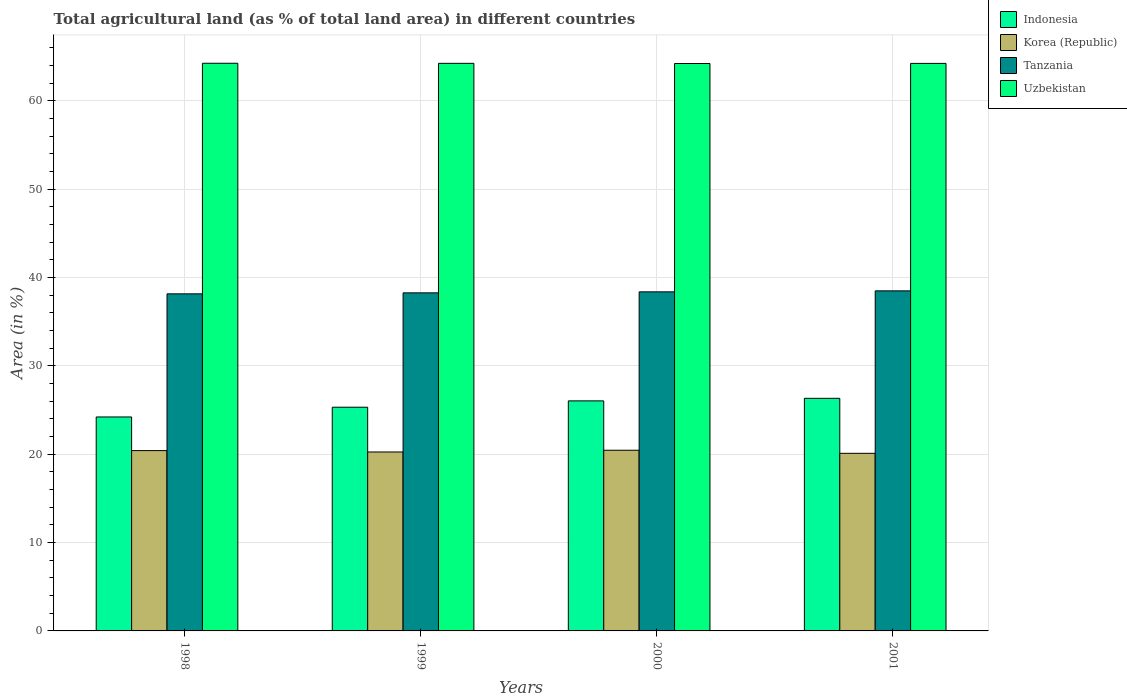Are the number of bars per tick equal to the number of legend labels?
Your answer should be compact. Yes. Are the number of bars on each tick of the X-axis equal?
Give a very brief answer. Yes. What is the percentage of agricultural land in Indonesia in 1998?
Provide a succinct answer. 24.22. Across all years, what is the maximum percentage of agricultural land in Tanzania?
Your answer should be compact. 38.5. Across all years, what is the minimum percentage of agricultural land in Korea (Republic)?
Give a very brief answer. 20.11. In which year was the percentage of agricultural land in Indonesia minimum?
Your answer should be compact. 1998. What is the total percentage of agricultural land in Tanzania in the graph?
Offer a very short reply. 153.31. What is the difference between the percentage of agricultural land in Korea (Republic) in 1998 and that in 1999?
Your answer should be compact. 0.16. What is the difference between the percentage of agricultural land in Indonesia in 2000 and the percentage of agricultural land in Korea (Republic) in 2001?
Offer a very short reply. 5.94. What is the average percentage of agricultural land in Uzbekistan per year?
Provide a succinct answer. 64.25. In the year 2001, what is the difference between the percentage of agricultural land in Korea (Republic) and percentage of agricultural land in Indonesia?
Your answer should be compact. -6.23. In how many years, is the percentage of agricultural land in Tanzania greater than 60 %?
Provide a succinct answer. 0. What is the ratio of the percentage of agricultural land in Uzbekistan in 1999 to that in 2001?
Offer a very short reply. 1. Is the percentage of agricultural land in Uzbekistan in 1999 less than that in 2000?
Ensure brevity in your answer.  No. What is the difference between the highest and the second highest percentage of agricultural land in Indonesia?
Provide a short and direct response. 0.29. What is the difference between the highest and the lowest percentage of agricultural land in Uzbekistan?
Keep it short and to the point. 0.03. Is it the case that in every year, the sum of the percentage of agricultural land in Indonesia and percentage of agricultural land in Tanzania is greater than the sum of percentage of agricultural land in Uzbekistan and percentage of agricultural land in Korea (Republic)?
Offer a very short reply. Yes. What does the 1st bar from the left in 1998 represents?
Provide a succinct answer. Indonesia. What does the 1st bar from the right in 1998 represents?
Offer a very short reply. Uzbekistan. How many bars are there?
Keep it short and to the point. 16. Are all the bars in the graph horizontal?
Provide a short and direct response. No. How many years are there in the graph?
Offer a very short reply. 4. What is the difference between two consecutive major ticks on the Y-axis?
Give a very brief answer. 10. Does the graph contain any zero values?
Keep it short and to the point. No. Where does the legend appear in the graph?
Your answer should be compact. Top right. How many legend labels are there?
Keep it short and to the point. 4. How are the legend labels stacked?
Keep it short and to the point. Vertical. What is the title of the graph?
Your answer should be very brief. Total agricultural land (as % of total land area) in different countries. Does "Vanuatu" appear as one of the legend labels in the graph?
Your response must be concise. No. What is the label or title of the X-axis?
Make the answer very short. Years. What is the label or title of the Y-axis?
Offer a very short reply. Area (in %). What is the Area (in %) in Indonesia in 1998?
Give a very brief answer. 24.22. What is the Area (in %) in Korea (Republic) in 1998?
Offer a terse response. 20.41. What is the Area (in %) of Tanzania in 1998?
Your answer should be very brief. 38.16. What is the Area (in %) in Uzbekistan in 1998?
Provide a short and direct response. 64.26. What is the Area (in %) of Indonesia in 1999?
Offer a very short reply. 25.32. What is the Area (in %) of Korea (Republic) in 1999?
Provide a short and direct response. 20.26. What is the Area (in %) in Tanzania in 1999?
Ensure brevity in your answer.  38.27. What is the Area (in %) of Uzbekistan in 1999?
Make the answer very short. 64.25. What is the Area (in %) of Indonesia in 2000?
Make the answer very short. 26.04. What is the Area (in %) of Korea (Republic) in 2000?
Ensure brevity in your answer.  20.45. What is the Area (in %) in Tanzania in 2000?
Keep it short and to the point. 38.38. What is the Area (in %) of Uzbekistan in 2000?
Your response must be concise. 64.23. What is the Area (in %) in Indonesia in 2001?
Keep it short and to the point. 26.33. What is the Area (in %) in Korea (Republic) in 2001?
Ensure brevity in your answer.  20.11. What is the Area (in %) of Tanzania in 2001?
Keep it short and to the point. 38.5. What is the Area (in %) of Uzbekistan in 2001?
Make the answer very short. 64.25. Across all years, what is the maximum Area (in %) in Indonesia?
Provide a short and direct response. 26.33. Across all years, what is the maximum Area (in %) of Korea (Republic)?
Provide a succinct answer. 20.45. Across all years, what is the maximum Area (in %) in Tanzania?
Give a very brief answer. 38.5. Across all years, what is the maximum Area (in %) in Uzbekistan?
Make the answer very short. 64.26. Across all years, what is the minimum Area (in %) of Indonesia?
Your answer should be compact. 24.22. Across all years, what is the minimum Area (in %) of Korea (Republic)?
Provide a succinct answer. 20.11. Across all years, what is the minimum Area (in %) of Tanzania?
Give a very brief answer. 38.16. Across all years, what is the minimum Area (in %) of Uzbekistan?
Make the answer very short. 64.23. What is the total Area (in %) in Indonesia in the graph?
Your answer should be very brief. 101.92. What is the total Area (in %) of Korea (Republic) in the graph?
Offer a very short reply. 81.23. What is the total Area (in %) of Tanzania in the graph?
Provide a short and direct response. 153.31. What is the total Area (in %) in Uzbekistan in the graph?
Keep it short and to the point. 256.99. What is the difference between the Area (in %) in Indonesia in 1998 and that in 1999?
Give a very brief answer. -1.1. What is the difference between the Area (in %) of Korea (Republic) in 1998 and that in 1999?
Your answer should be very brief. 0.16. What is the difference between the Area (in %) in Tanzania in 1998 and that in 1999?
Your answer should be very brief. -0.11. What is the difference between the Area (in %) in Uzbekistan in 1998 and that in 1999?
Keep it short and to the point. 0.01. What is the difference between the Area (in %) in Indonesia in 1998 and that in 2000?
Your response must be concise. -1.82. What is the difference between the Area (in %) in Korea (Republic) in 1998 and that in 2000?
Make the answer very short. -0.04. What is the difference between the Area (in %) of Tanzania in 1998 and that in 2000?
Keep it short and to the point. -0.23. What is the difference between the Area (in %) in Uzbekistan in 1998 and that in 2000?
Make the answer very short. 0.03. What is the difference between the Area (in %) of Indonesia in 1998 and that in 2001?
Ensure brevity in your answer.  -2.11. What is the difference between the Area (in %) of Korea (Republic) in 1998 and that in 2001?
Offer a terse response. 0.31. What is the difference between the Area (in %) of Tanzania in 1998 and that in 2001?
Keep it short and to the point. -0.34. What is the difference between the Area (in %) of Uzbekistan in 1998 and that in 2001?
Make the answer very short. 0.02. What is the difference between the Area (in %) of Indonesia in 1999 and that in 2000?
Give a very brief answer. -0.72. What is the difference between the Area (in %) of Korea (Republic) in 1999 and that in 2000?
Keep it short and to the point. -0.2. What is the difference between the Area (in %) of Tanzania in 1999 and that in 2000?
Provide a succinct answer. -0.11. What is the difference between the Area (in %) of Uzbekistan in 1999 and that in 2000?
Your answer should be compact. 0.02. What is the difference between the Area (in %) in Indonesia in 1999 and that in 2001?
Your answer should be very brief. -1.01. What is the difference between the Area (in %) in Korea (Republic) in 1999 and that in 2001?
Give a very brief answer. 0.15. What is the difference between the Area (in %) of Tanzania in 1999 and that in 2001?
Offer a very short reply. -0.23. What is the difference between the Area (in %) of Uzbekistan in 1999 and that in 2001?
Offer a terse response. 0.01. What is the difference between the Area (in %) in Indonesia in 2000 and that in 2001?
Make the answer very short. -0.29. What is the difference between the Area (in %) of Korea (Republic) in 2000 and that in 2001?
Your response must be concise. 0.35. What is the difference between the Area (in %) of Tanzania in 2000 and that in 2001?
Provide a short and direct response. -0.11. What is the difference between the Area (in %) in Uzbekistan in 2000 and that in 2001?
Offer a terse response. -0.01. What is the difference between the Area (in %) of Indonesia in 1998 and the Area (in %) of Korea (Republic) in 1999?
Provide a succinct answer. 3.96. What is the difference between the Area (in %) of Indonesia in 1998 and the Area (in %) of Tanzania in 1999?
Offer a very short reply. -14.05. What is the difference between the Area (in %) in Indonesia in 1998 and the Area (in %) in Uzbekistan in 1999?
Offer a terse response. -40.03. What is the difference between the Area (in %) of Korea (Republic) in 1998 and the Area (in %) of Tanzania in 1999?
Your response must be concise. -17.86. What is the difference between the Area (in %) in Korea (Republic) in 1998 and the Area (in %) in Uzbekistan in 1999?
Offer a very short reply. -43.84. What is the difference between the Area (in %) of Tanzania in 1998 and the Area (in %) of Uzbekistan in 1999?
Make the answer very short. -26.09. What is the difference between the Area (in %) of Indonesia in 1998 and the Area (in %) of Korea (Republic) in 2000?
Your answer should be very brief. 3.77. What is the difference between the Area (in %) of Indonesia in 1998 and the Area (in %) of Tanzania in 2000?
Provide a succinct answer. -14.16. What is the difference between the Area (in %) in Indonesia in 1998 and the Area (in %) in Uzbekistan in 2000?
Provide a succinct answer. -40.01. What is the difference between the Area (in %) of Korea (Republic) in 1998 and the Area (in %) of Tanzania in 2000?
Make the answer very short. -17.97. What is the difference between the Area (in %) in Korea (Republic) in 1998 and the Area (in %) in Uzbekistan in 2000?
Offer a terse response. -43.82. What is the difference between the Area (in %) in Tanzania in 1998 and the Area (in %) in Uzbekistan in 2000?
Your response must be concise. -26.08. What is the difference between the Area (in %) of Indonesia in 1998 and the Area (in %) of Korea (Republic) in 2001?
Offer a very short reply. 4.12. What is the difference between the Area (in %) of Indonesia in 1998 and the Area (in %) of Tanzania in 2001?
Give a very brief answer. -14.28. What is the difference between the Area (in %) of Indonesia in 1998 and the Area (in %) of Uzbekistan in 2001?
Give a very brief answer. -40.02. What is the difference between the Area (in %) of Korea (Republic) in 1998 and the Area (in %) of Tanzania in 2001?
Your answer should be compact. -18.08. What is the difference between the Area (in %) of Korea (Republic) in 1998 and the Area (in %) of Uzbekistan in 2001?
Make the answer very short. -43.83. What is the difference between the Area (in %) in Tanzania in 1998 and the Area (in %) in Uzbekistan in 2001?
Make the answer very short. -26.09. What is the difference between the Area (in %) of Indonesia in 1999 and the Area (in %) of Korea (Republic) in 2000?
Give a very brief answer. 4.87. What is the difference between the Area (in %) of Indonesia in 1999 and the Area (in %) of Tanzania in 2000?
Provide a short and direct response. -13.06. What is the difference between the Area (in %) of Indonesia in 1999 and the Area (in %) of Uzbekistan in 2000?
Your answer should be very brief. -38.91. What is the difference between the Area (in %) of Korea (Republic) in 1999 and the Area (in %) of Tanzania in 2000?
Give a very brief answer. -18.13. What is the difference between the Area (in %) in Korea (Republic) in 1999 and the Area (in %) in Uzbekistan in 2000?
Offer a very short reply. -43.98. What is the difference between the Area (in %) of Tanzania in 1999 and the Area (in %) of Uzbekistan in 2000?
Make the answer very short. -25.96. What is the difference between the Area (in %) in Indonesia in 1999 and the Area (in %) in Korea (Republic) in 2001?
Give a very brief answer. 5.22. What is the difference between the Area (in %) in Indonesia in 1999 and the Area (in %) in Tanzania in 2001?
Make the answer very short. -13.17. What is the difference between the Area (in %) in Indonesia in 1999 and the Area (in %) in Uzbekistan in 2001?
Make the answer very short. -38.92. What is the difference between the Area (in %) in Korea (Republic) in 1999 and the Area (in %) in Tanzania in 2001?
Your answer should be compact. -18.24. What is the difference between the Area (in %) of Korea (Republic) in 1999 and the Area (in %) of Uzbekistan in 2001?
Provide a succinct answer. -43.99. What is the difference between the Area (in %) of Tanzania in 1999 and the Area (in %) of Uzbekistan in 2001?
Ensure brevity in your answer.  -25.97. What is the difference between the Area (in %) in Indonesia in 2000 and the Area (in %) in Korea (Republic) in 2001?
Provide a short and direct response. 5.94. What is the difference between the Area (in %) in Indonesia in 2000 and the Area (in %) in Tanzania in 2001?
Provide a short and direct response. -12.45. What is the difference between the Area (in %) in Indonesia in 2000 and the Area (in %) in Uzbekistan in 2001?
Keep it short and to the point. -38.2. What is the difference between the Area (in %) in Korea (Republic) in 2000 and the Area (in %) in Tanzania in 2001?
Keep it short and to the point. -18.04. What is the difference between the Area (in %) of Korea (Republic) in 2000 and the Area (in %) of Uzbekistan in 2001?
Provide a succinct answer. -43.79. What is the difference between the Area (in %) of Tanzania in 2000 and the Area (in %) of Uzbekistan in 2001?
Make the answer very short. -25.86. What is the average Area (in %) in Indonesia per year?
Offer a very short reply. 25.48. What is the average Area (in %) in Korea (Republic) per year?
Your response must be concise. 20.31. What is the average Area (in %) of Tanzania per year?
Offer a terse response. 38.33. What is the average Area (in %) of Uzbekistan per year?
Your response must be concise. 64.25. In the year 1998, what is the difference between the Area (in %) in Indonesia and Area (in %) in Korea (Republic)?
Keep it short and to the point. 3.81. In the year 1998, what is the difference between the Area (in %) of Indonesia and Area (in %) of Tanzania?
Offer a terse response. -13.94. In the year 1998, what is the difference between the Area (in %) in Indonesia and Area (in %) in Uzbekistan?
Your answer should be very brief. -40.04. In the year 1998, what is the difference between the Area (in %) in Korea (Republic) and Area (in %) in Tanzania?
Make the answer very short. -17.75. In the year 1998, what is the difference between the Area (in %) in Korea (Republic) and Area (in %) in Uzbekistan?
Your answer should be compact. -43.85. In the year 1998, what is the difference between the Area (in %) in Tanzania and Area (in %) in Uzbekistan?
Make the answer very short. -26.1. In the year 1999, what is the difference between the Area (in %) in Indonesia and Area (in %) in Korea (Republic)?
Your answer should be compact. 5.07. In the year 1999, what is the difference between the Area (in %) of Indonesia and Area (in %) of Tanzania?
Ensure brevity in your answer.  -12.95. In the year 1999, what is the difference between the Area (in %) of Indonesia and Area (in %) of Uzbekistan?
Your answer should be compact. -38.93. In the year 1999, what is the difference between the Area (in %) in Korea (Republic) and Area (in %) in Tanzania?
Your answer should be very brief. -18.01. In the year 1999, what is the difference between the Area (in %) of Korea (Republic) and Area (in %) of Uzbekistan?
Keep it short and to the point. -44. In the year 1999, what is the difference between the Area (in %) in Tanzania and Area (in %) in Uzbekistan?
Your response must be concise. -25.98. In the year 2000, what is the difference between the Area (in %) in Indonesia and Area (in %) in Korea (Republic)?
Your response must be concise. 5.59. In the year 2000, what is the difference between the Area (in %) of Indonesia and Area (in %) of Tanzania?
Keep it short and to the point. -12.34. In the year 2000, what is the difference between the Area (in %) in Indonesia and Area (in %) in Uzbekistan?
Your response must be concise. -38.19. In the year 2000, what is the difference between the Area (in %) in Korea (Republic) and Area (in %) in Tanzania?
Keep it short and to the point. -17.93. In the year 2000, what is the difference between the Area (in %) in Korea (Republic) and Area (in %) in Uzbekistan?
Your answer should be compact. -43.78. In the year 2000, what is the difference between the Area (in %) in Tanzania and Area (in %) in Uzbekistan?
Offer a terse response. -25.85. In the year 2001, what is the difference between the Area (in %) of Indonesia and Area (in %) of Korea (Republic)?
Keep it short and to the point. 6.23. In the year 2001, what is the difference between the Area (in %) of Indonesia and Area (in %) of Tanzania?
Provide a succinct answer. -12.17. In the year 2001, what is the difference between the Area (in %) in Indonesia and Area (in %) in Uzbekistan?
Provide a succinct answer. -37.91. In the year 2001, what is the difference between the Area (in %) in Korea (Republic) and Area (in %) in Tanzania?
Your answer should be very brief. -18.39. In the year 2001, what is the difference between the Area (in %) in Korea (Republic) and Area (in %) in Uzbekistan?
Your answer should be very brief. -44.14. In the year 2001, what is the difference between the Area (in %) in Tanzania and Area (in %) in Uzbekistan?
Offer a very short reply. -25.75. What is the ratio of the Area (in %) in Indonesia in 1998 to that in 1999?
Provide a short and direct response. 0.96. What is the ratio of the Area (in %) of Korea (Republic) in 1998 to that in 1999?
Make the answer very short. 1.01. What is the ratio of the Area (in %) of Tanzania in 1998 to that in 1999?
Provide a succinct answer. 1. What is the ratio of the Area (in %) in Indonesia in 1998 to that in 2000?
Ensure brevity in your answer.  0.93. What is the ratio of the Area (in %) of Korea (Republic) in 1998 to that in 2000?
Provide a succinct answer. 1. What is the ratio of the Area (in %) in Indonesia in 1998 to that in 2001?
Give a very brief answer. 0.92. What is the ratio of the Area (in %) in Korea (Republic) in 1998 to that in 2001?
Offer a terse response. 1.02. What is the ratio of the Area (in %) in Indonesia in 1999 to that in 2000?
Your response must be concise. 0.97. What is the ratio of the Area (in %) in Korea (Republic) in 1999 to that in 2000?
Keep it short and to the point. 0.99. What is the ratio of the Area (in %) in Uzbekistan in 1999 to that in 2000?
Provide a succinct answer. 1. What is the ratio of the Area (in %) of Indonesia in 1999 to that in 2001?
Provide a succinct answer. 0.96. What is the ratio of the Area (in %) in Korea (Republic) in 1999 to that in 2001?
Make the answer very short. 1.01. What is the ratio of the Area (in %) of Tanzania in 1999 to that in 2001?
Your answer should be very brief. 0.99. What is the ratio of the Area (in %) in Uzbekistan in 1999 to that in 2001?
Provide a short and direct response. 1. What is the ratio of the Area (in %) of Korea (Republic) in 2000 to that in 2001?
Offer a very short reply. 1.02. What is the ratio of the Area (in %) of Tanzania in 2000 to that in 2001?
Your answer should be compact. 1. What is the ratio of the Area (in %) of Uzbekistan in 2000 to that in 2001?
Offer a terse response. 1. What is the difference between the highest and the second highest Area (in %) of Indonesia?
Offer a very short reply. 0.29. What is the difference between the highest and the second highest Area (in %) of Korea (Republic)?
Your answer should be compact. 0.04. What is the difference between the highest and the second highest Area (in %) in Tanzania?
Your answer should be compact. 0.11. What is the difference between the highest and the second highest Area (in %) of Uzbekistan?
Provide a succinct answer. 0.01. What is the difference between the highest and the lowest Area (in %) in Indonesia?
Offer a terse response. 2.11. What is the difference between the highest and the lowest Area (in %) of Korea (Republic)?
Your response must be concise. 0.35. What is the difference between the highest and the lowest Area (in %) in Tanzania?
Give a very brief answer. 0.34. What is the difference between the highest and the lowest Area (in %) in Uzbekistan?
Your answer should be very brief. 0.03. 